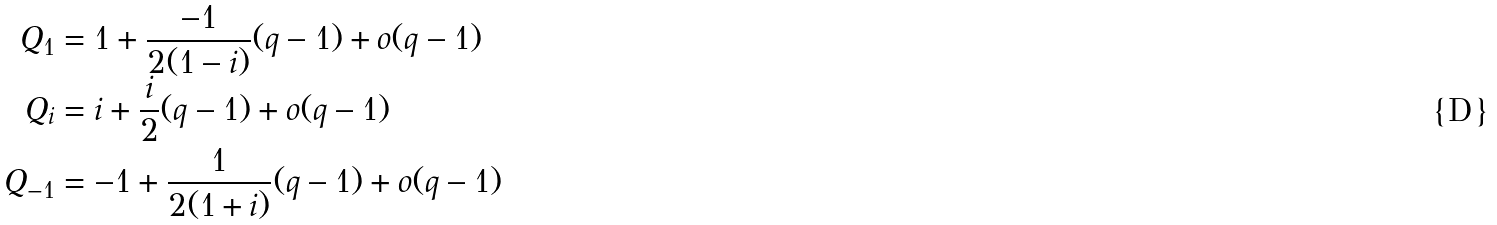<formula> <loc_0><loc_0><loc_500><loc_500>Q _ { 1 } & = 1 + \frac { - 1 } { 2 ( 1 - i ) } ( q - 1 ) + o ( q - 1 ) \\ Q _ { i } & = i + \frac { i } { 2 } ( q - 1 ) + o ( q - 1 ) \\ Q _ { - 1 } & = - 1 + \frac { 1 } { 2 ( 1 + i ) } ( q - 1 ) + o ( q - 1 )</formula> 